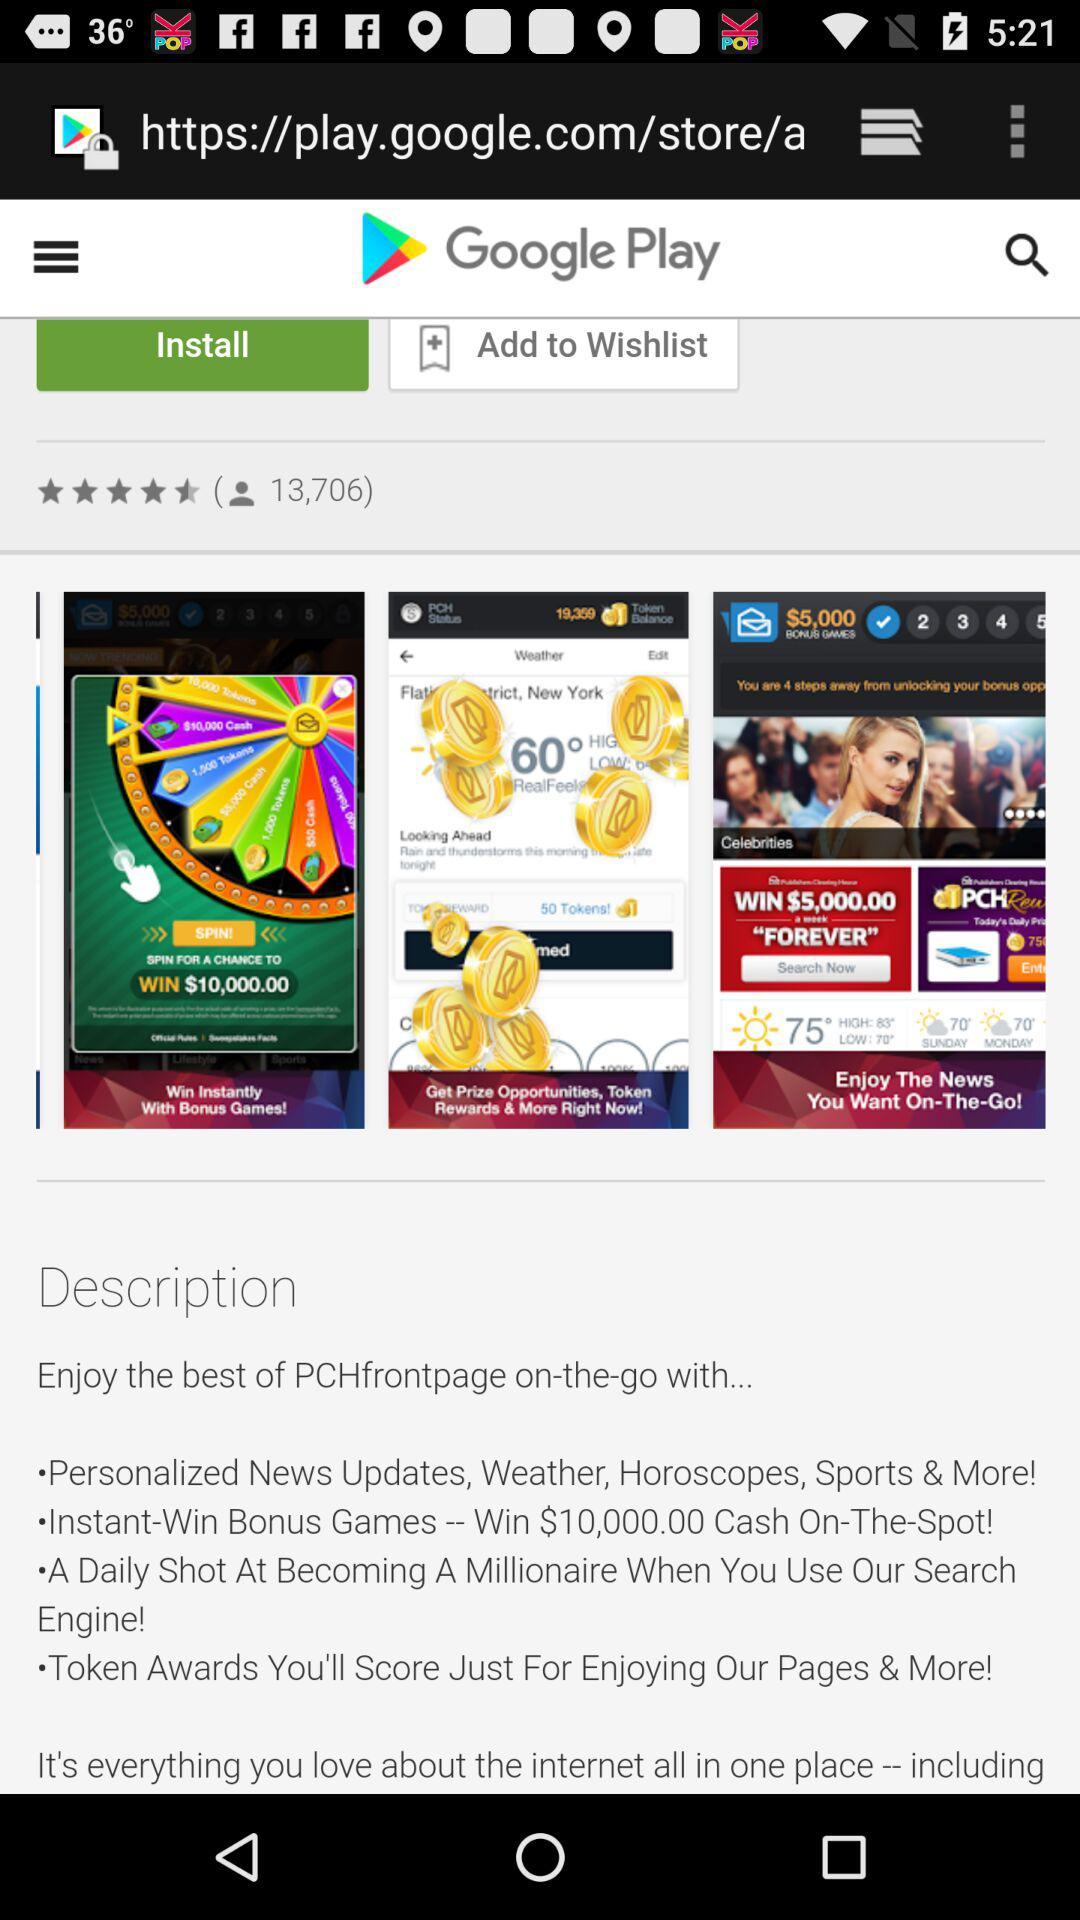How many people views?
When the provided information is insufficient, respond with <no answer>. <no answer> 